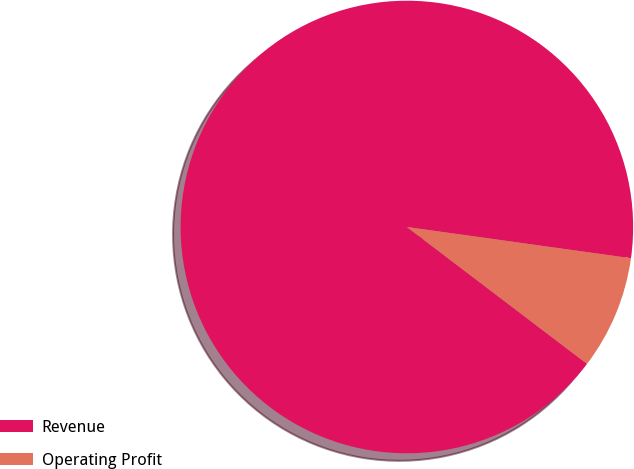<chart> <loc_0><loc_0><loc_500><loc_500><pie_chart><fcel>Revenue<fcel>Operating Profit<nl><fcel>91.86%<fcel>8.14%<nl></chart> 